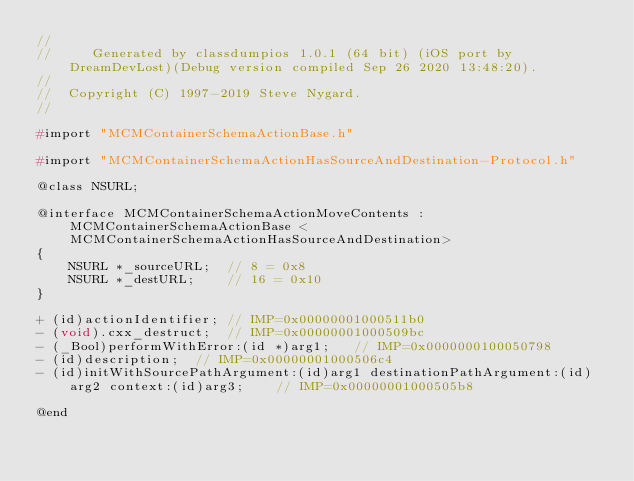Convert code to text. <code><loc_0><loc_0><loc_500><loc_500><_C_>//
//     Generated by classdumpios 1.0.1 (64 bit) (iOS port by DreamDevLost)(Debug version compiled Sep 26 2020 13:48:20).
//
//  Copyright (C) 1997-2019 Steve Nygard.
//

#import "MCMContainerSchemaActionBase.h"

#import "MCMContainerSchemaActionHasSourceAndDestination-Protocol.h"

@class NSURL;

@interface MCMContainerSchemaActionMoveContents : MCMContainerSchemaActionBase <MCMContainerSchemaActionHasSourceAndDestination>
{
    NSURL *_sourceURL;	// 8 = 0x8
    NSURL *_destURL;	// 16 = 0x10
}

+ (id)actionIdentifier;	// IMP=0x00000001000511b0
- (void).cxx_destruct;	// IMP=0x00000001000509bc
- (_Bool)performWithError:(id *)arg1;	// IMP=0x0000000100050798
- (id)description;	// IMP=0x00000001000506c4
- (id)initWithSourcePathArgument:(id)arg1 destinationPathArgument:(id)arg2 context:(id)arg3;	// IMP=0x00000001000505b8

@end

</code> 